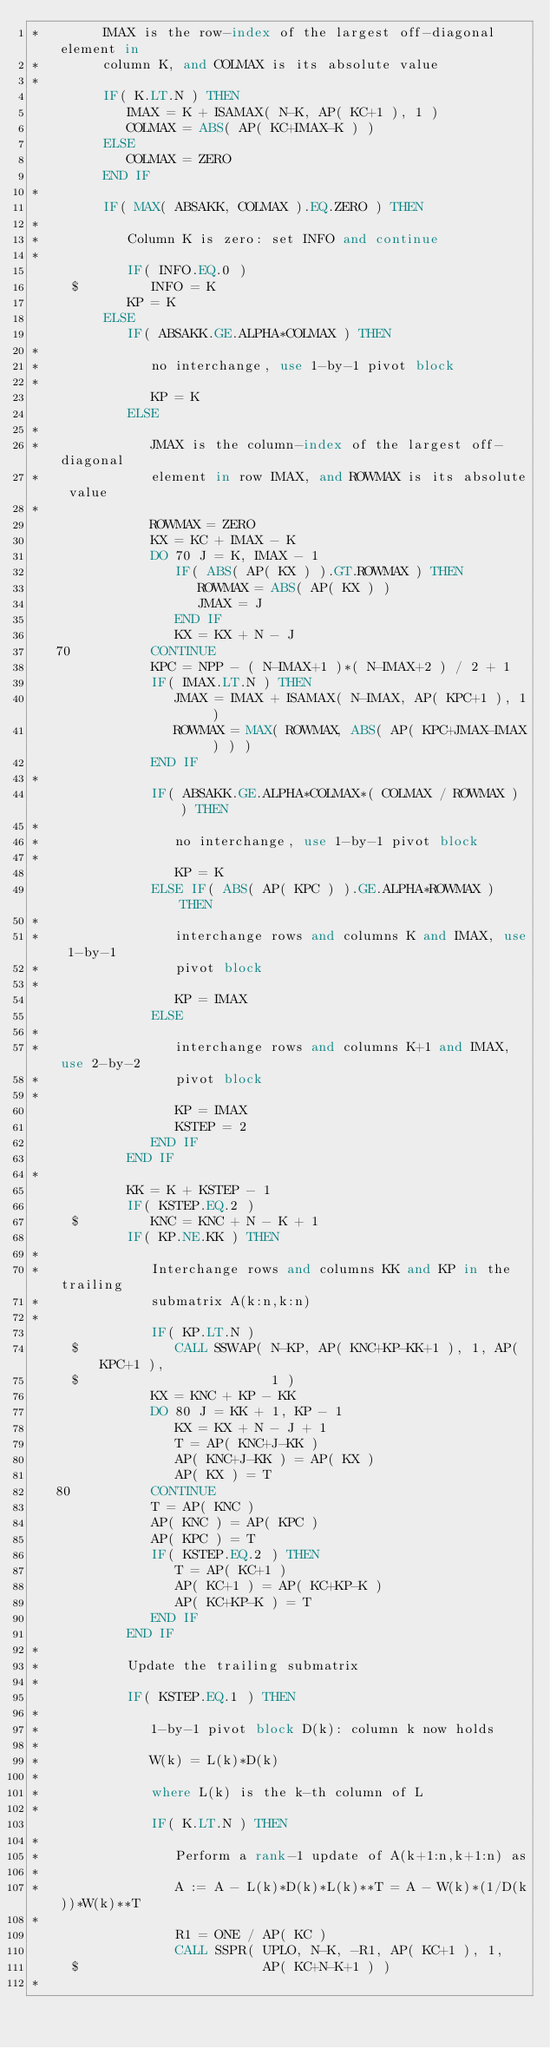<code> <loc_0><loc_0><loc_500><loc_500><_FORTRAN_>*        IMAX is the row-index of the largest off-diagonal element in
*        column K, and COLMAX is its absolute value
*
         IF( K.LT.N ) THEN
            IMAX = K + ISAMAX( N-K, AP( KC+1 ), 1 )
            COLMAX = ABS( AP( KC+IMAX-K ) )
         ELSE
            COLMAX = ZERO
         END IF
*
         IF( MAX( ABSAKK, COLMAX ).EQ.ZERO ) THEN
*
*           Column K is zero: set INFO and continue
*
            IF( INFO.EQ.0 )
     $         INFO = K
            KP = K
         ELSE
            IF( ABSAKK.GE.ALPHA*COLMAX ) THEN
*
*              no interchange, use 1-by-1 pivot block
*
               KP = K
            ELSE
*
*              JMAX is the column-index of the largest off-diagonal
*              element in row IMAX, and ROWMAX is its absolute value
*
               ROWMAX = ZERO
               KX = KC + IMAX - K
               DO 70 J = K, IMAX - 1
                  IF( ABS( AP( KX ) ).GT.ROWMAX ) THEN
                     ROWMAX = ABS( AP( KX ) )
                     JMAX = J
                  END IF
                  KX = KX + N - J
   70          CONTINUE
               KPC = NPP - ( N-IMAX+1 )*( N-IMAX+2 ) / 2 + 1
               IF( IMAX.LT.N ) THEN
                  JMAX = IMAX + ISAMAX( N-IMAX, AP( KPC+1 ), 1 )
                  ROWMAX = MAX( ROWMAX, ABS( AP( KPC+JMAX-IMAX ) ) )
               END IF
*
               IF( ABSAKK.GE.ALPHA*COLMAX*( COLMAX / ROWMAX ) ) THEN
*
*                 no interchange, use 1-by-1 pivot block
*
                  KP = K
               ELSE IF( ABS( AP( KPC ) ).GE.ALPHA*ROWMAX ) THEN
*
*                 interchange rows and columns K and IMAX, use 1-by-1
*                 pivot block
*
                  KP = IMAX
               ELSE
*
*                 interchange rows and columns K+1 and IMAX, use 2-by-2
*                 pivot block
*
                  KP = IMAX
                  KSTEP = 2
               END IF
            END IF
*
            KK = K + KSTEP - 1
            IF( KSTEP.EQ.2 )
     $         KNC = KNC + N - K + 1
            IF( KP.NE.KK ) THEN
*
*              Interchange rows and columns KK and KP in the trailing
*              submatrix A(k:n,k:n)
*
               IF( KP.LT.N )
     $            CALL SSWAP( N-KP, AP( KNC+KP-KK+1 ), 1, AP( KPC+1 ),
     $                        1 )
               KX = KNC + KP - KK
               DO 80 J = KK + 1, KP - 1
                  KX = KX + N - J + 1
                  T = AP( KNC+J-KK )
                  AP( KNC+J-KK ) = AP( KX )
                  AP( KX ) = T
   80          CONTINUE
               T = AP( KNC )
               AP( KNC ) = AP( KPC )
               AP( KPC ) = T
               IF( KSTEP.EQ.2 ) THEN
                  T = AP( KC+1 )
                  AP( KC+1 ) = AP( KC+KP-K )
                  AP( KC+KP-K ) = T
               END IF
            END IF
*
*           Update the trailing submatrix
*
            IF( KSTEP.EQ.1 ) THEN
*
*              1-by-1 pivot block D(k): column k now holds
*
*              W(k) = L(k)*D(k)
*
*              where L(k) is the k-th column of L
*
               IF( K.LT.N ) THEN
*
*                 Perform a rank-1 update of A(k+1:n,k+1:n) as
*
*                 A := A - L(k)*D(k)*L(k)**T = A - W(k)*(1/D(k))*W(k)**T
*
                  R1 = ONE / AP( KC )
                  CALL SSPR( UPLO, N-K, -R1, AP( KC+1 ), 1,
     $                       AP( KC+N-K+1 ) )
*</code> 